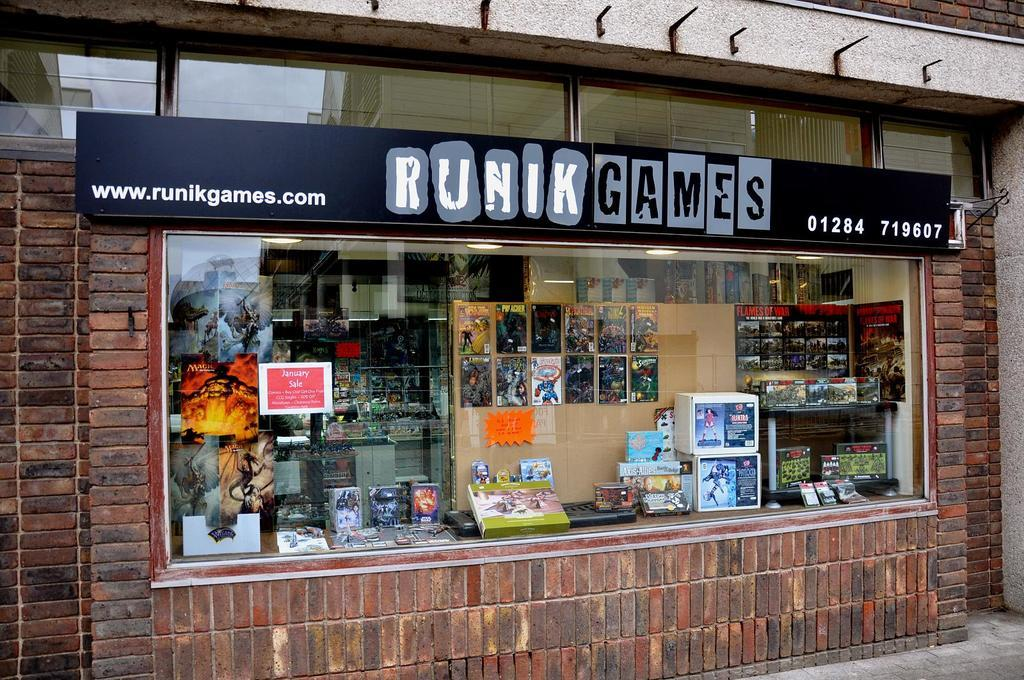What is located at the bottom of the image? There is a road at the bottom of the image. What can be seen in the corners of the image? There are walls on both the left and right corners of the image. What type of opening is present in the image? There is a glass window in the image. What can be observed through the glass window? Many objects are visible through the glass window. Is there any text present in the image? Yes, there is text present in the image. What type of jewel is being discussed in the office through the glass window? There is no office or jewel present in the image; it features a road, walls, a glass window, and text. 